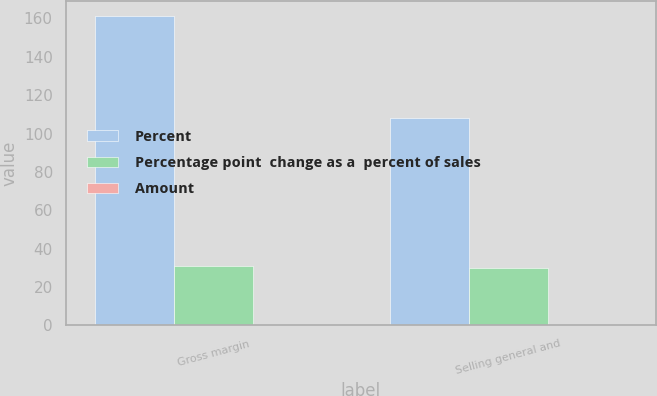Convert chart to OTSL. <chart><loc_0><loc_0><loc_500><loc_500><stacked_bar_chart><ecel><fcel>Gross margin<fcel>Selling general and<nl><fcel>Percent<fcel>161<fcel>108<nl><fcel>Percentage point  change as a  percent of sales<fcel>31<fcel>30<nl><fcel>Amount<fcel>0.1<fcel>0.1<nl></chart> 